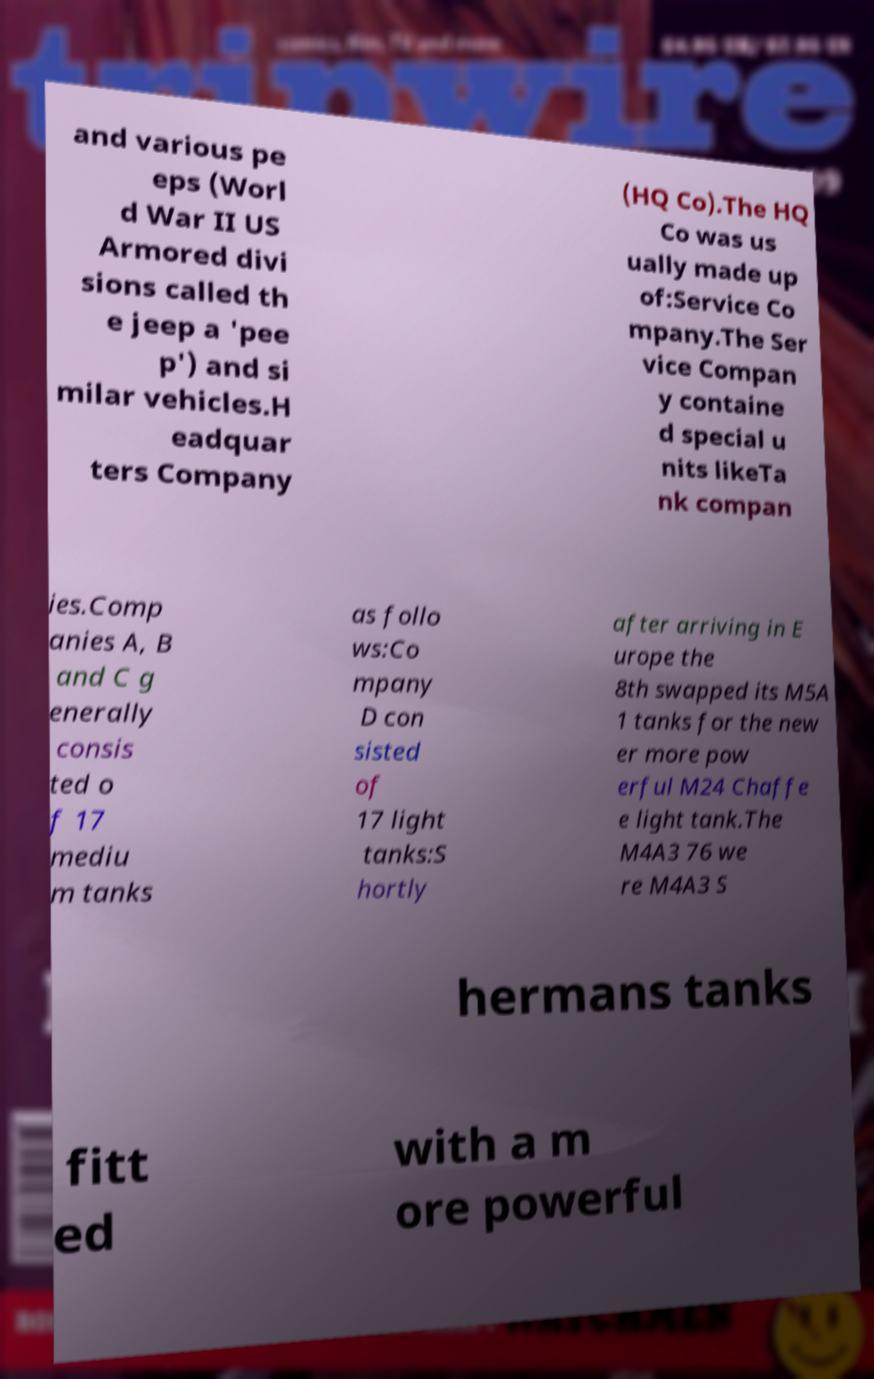Could you extract and type out the text from this image? and various pe eps (Worl d War II US Armored divi sions called th e jeep a 'pee p') and si milar vehicles.H eadquar ters Company (HQ Co).The HQ Co was us ually made up of:Service Co mpany.The Ser vice Compan y containe d special u nits likeTa nk compan ies.Comp anies A, B and C g enerally consis ted o f 17 mediu m tanks as follo ws:Co mpany D con sisted of 17 light tanks:S hortly after arriving in E urope the 8th swapped its M5A 1 tanks for the new er more pow erful M24 Chaffe e light tank.The M4A3 76 we re M4A3 S hermans tanks fitt ed with a m ore powerful 